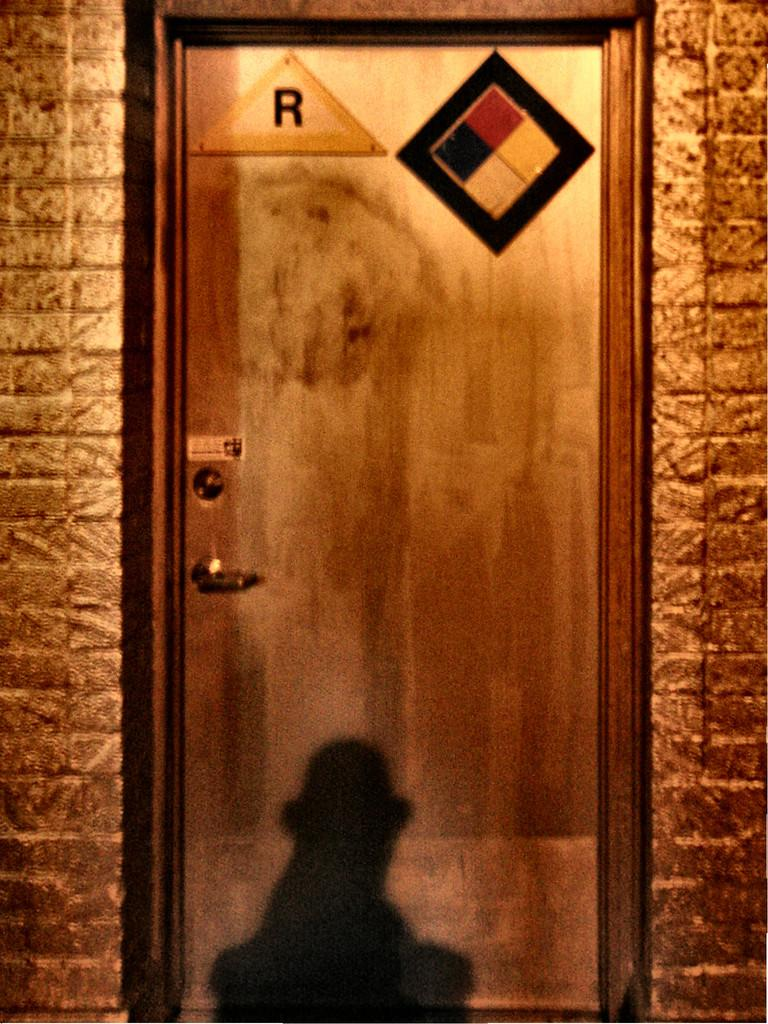What is one of the main structures visible in the image? There is a door in the image. What other architectural element can be seen in the image? There is a wall in the image. Can you describe any unique features of the door? There is a reflection on the door. What type of brass instrument is being played in the image? There is no brass instrument present in the image. What emotion might the person in the image be feeling, based on the reflection? The reflection on the door does not provide any information about the emotions of a person in the image. 